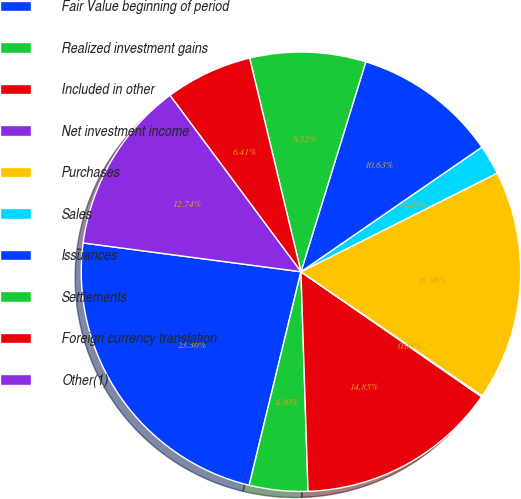Convert chart to OTSL. <chart><loc_0><loc_0><loc_500><loc_500><pie_chart><fcel>Fair Value beginning of period<fcel>Realized investment gains<fcel>Included in other<fcel>Net investment income<fcel>Purchases<fcel>Sales<fcel>Issuances<fcel>Settlements<fcel>Foreign currency translation<fcel>Other(1)<nl><fcel>23.3%<fcel>4.3%<fcel>14.85%<fcel>0.08%<fcel>16.96%<fcel>2.19%<fcel>10.63%<fcel>8.52%<fcel>6.41%<fcel>12.74%<nl></chart> 